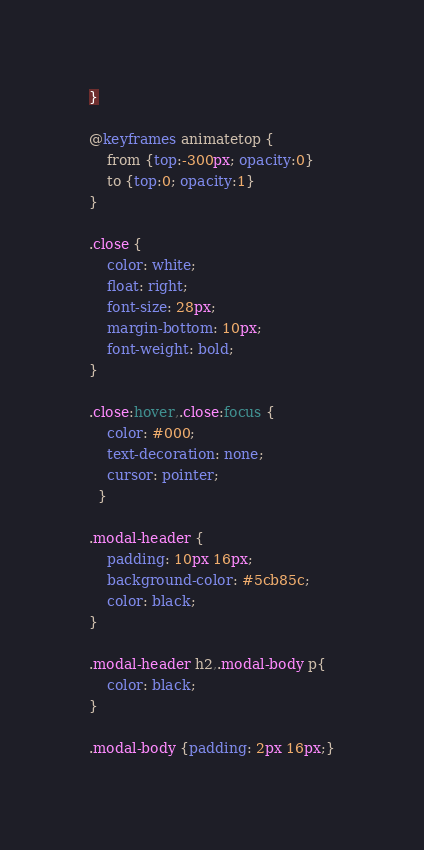<code> <loc_0><loc_0><loc_500><loc_500><_CSS_>}
  
@keyframes animatetop {
    from {top:-300px; opacity:0}
    to {top:0; opacity:1}
}
  
.close {
    color: white;
    float: right;
    font-size: 28px;
    margin-bottom: 10px;
    font-weight: bold;
}
  
.close:hover,.close:focus {
    color: #000;
    text-decoration: none;
    cursor: pointer;
  }
  
.modal-header {
    padding: 10px 16px;
    background-color: #5cb85c;
    color: black;
}

.modal-header h2,.modal-body p{
    color: black;
}
  
.modal-body {padding: 2px 16px;}</code> 